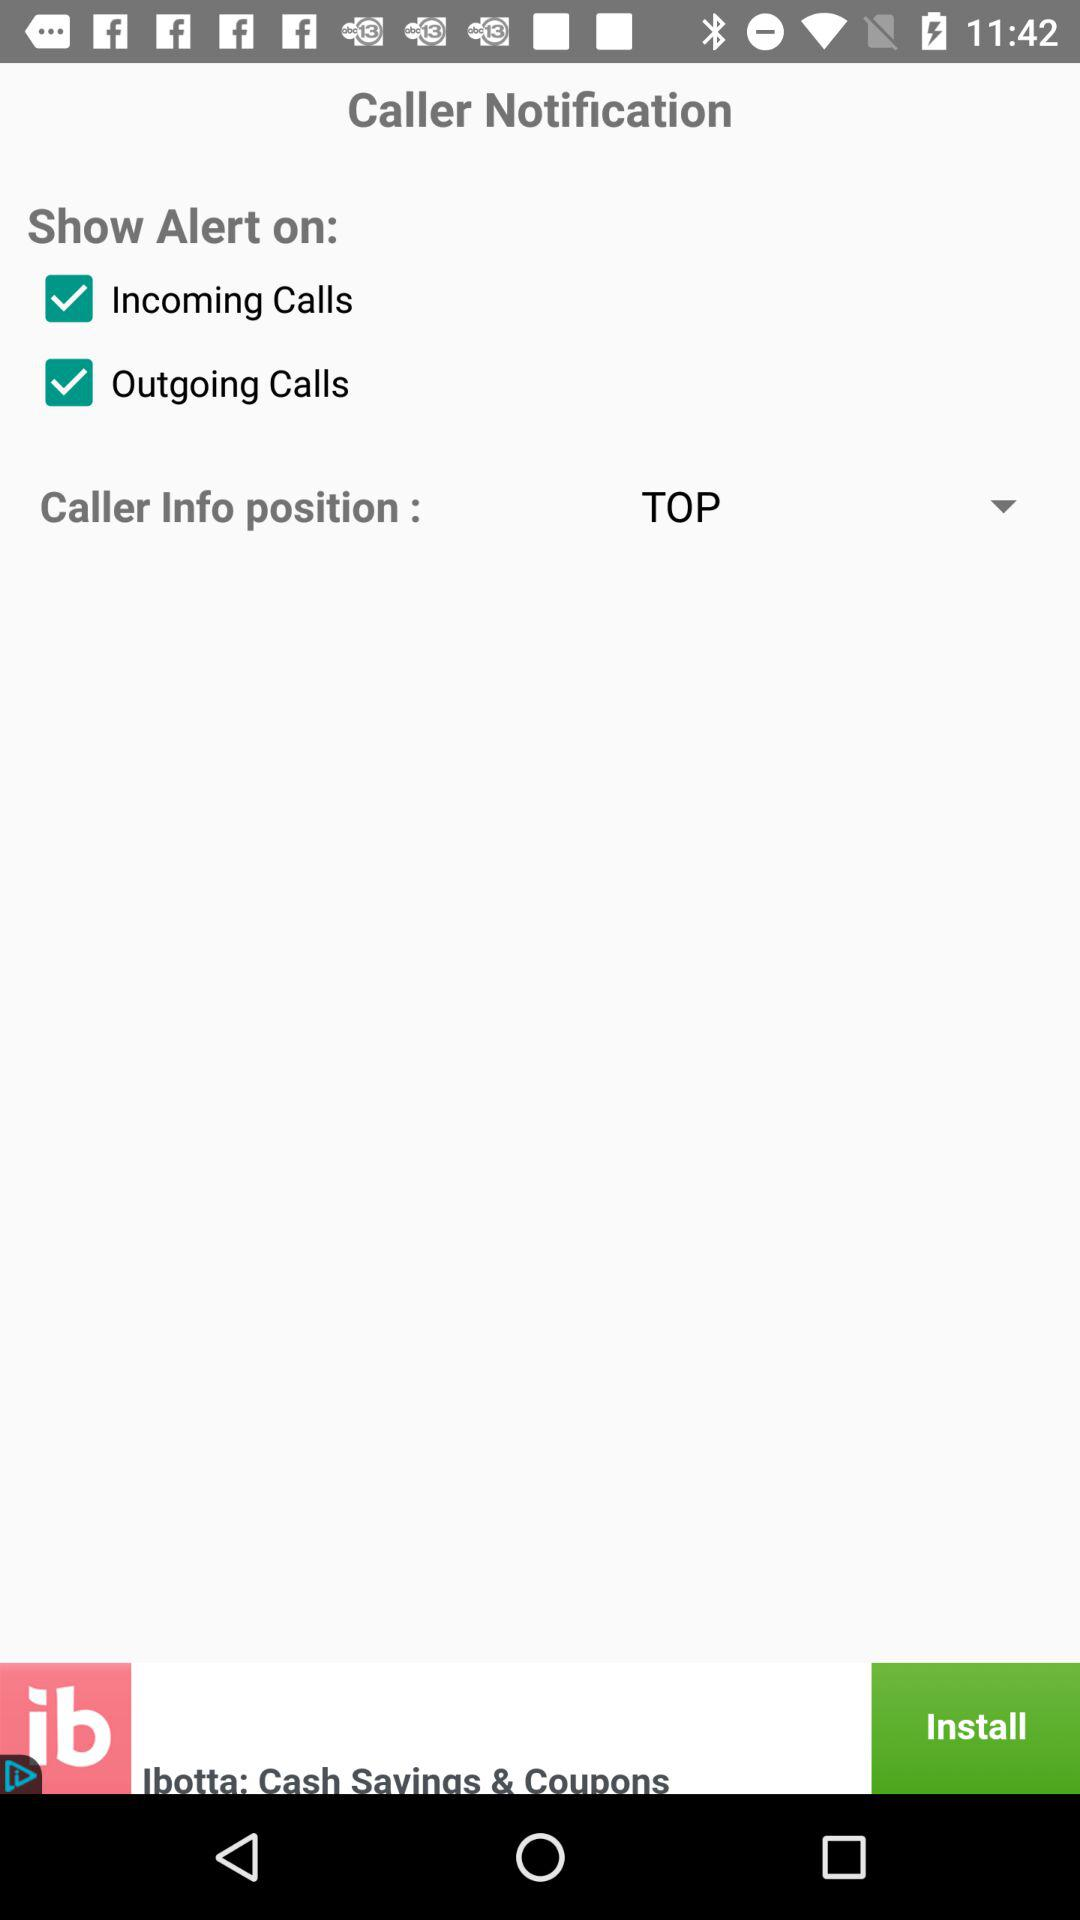What is the status of the outgoing calls? The status of the outgoing calls is on. 